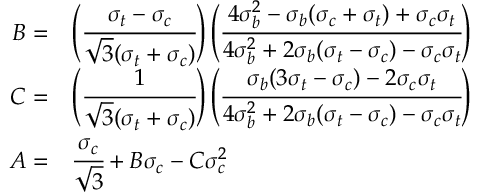Convert formula to latex. <formula><loc_0><loc_0><loc_500><loc_500>{ \begin{array} { r l } { B = } & { \left ( { \cfrac { \sigma _ { t } - \sigma _ { c } } { { \sqrt { 3 } } ( \sigma _ { t } + \sigma _ { c } ) } } \right ) \left ( { \cfrac { 4 \sigma _ { b } ^ { 2 } - \sigma _ { b } ( \sigma _ { c } + \sigma _ { t } ) + \sigma _ { c } \sigma _ { t } } { 4 \sigma _ { b } ^ { 2 } + 2 \sigma _ { b } ( \sigma _ { t } - \sigma _ { c } ) - \sigma _ { c } \sigma _ { t } } } \right ) } \\ { C = } & { \left ( { \cfrac { 1 } { { \sqrt { 3 } } ( \sigma _ { t } + \sigma _ { c } ) } } \right ) \left ( { \cfrac { \sigma _ { b } ( 3 \sigma _ { t } - \sigma _ { c } ) - 2 \sigma _ { c } \sigma _ { t } } { 4 \sigma _ { b } ^ { 2 } + 2 \sigma _ { b } ( \sigma _ { t } - \sigma _ { c } ) - \sigma _ { c } \sigma _ { t } } } \right ) } \\ { A = } & { { \cfrac { \sigma _ { c } } { \sqrt { 3 } } } + B \sigma _ { c } - C \sigma _ { c } ^ { 2 } } \end{array} }</formula> 